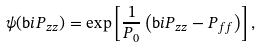Convert formula to latex. <formula><loc_0><loc_0><loc_500><loc_500>\psi ( \mathsf b i { P } _ { z z } ) = \exp \left [ \frac { 1 } { P _ { 0 } } \left ( \mathsf b i { P } _ { z z } - P _ { f f } \right ) \right ] ,</formula> 